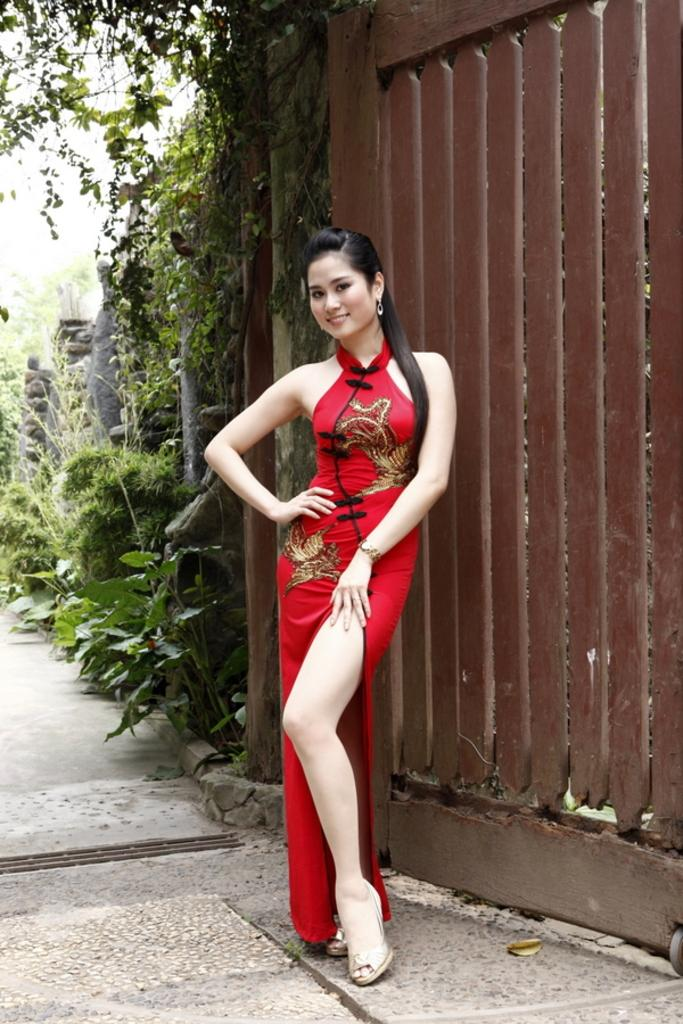Who is in the image? There is a woman in the image. What is the woman doing in the image? The woman is standing. What is the woman wearing in the image? The woman is wearing a red dress. What can be seen in the background of the image? There is a wooden gate in the background of the image. What type of vegetation is present in the image? There are plants present in the image. What type of alarm is the woman holding in the image? There is no alarm present in the image; the woman is simply standing and wearing a red dress. 